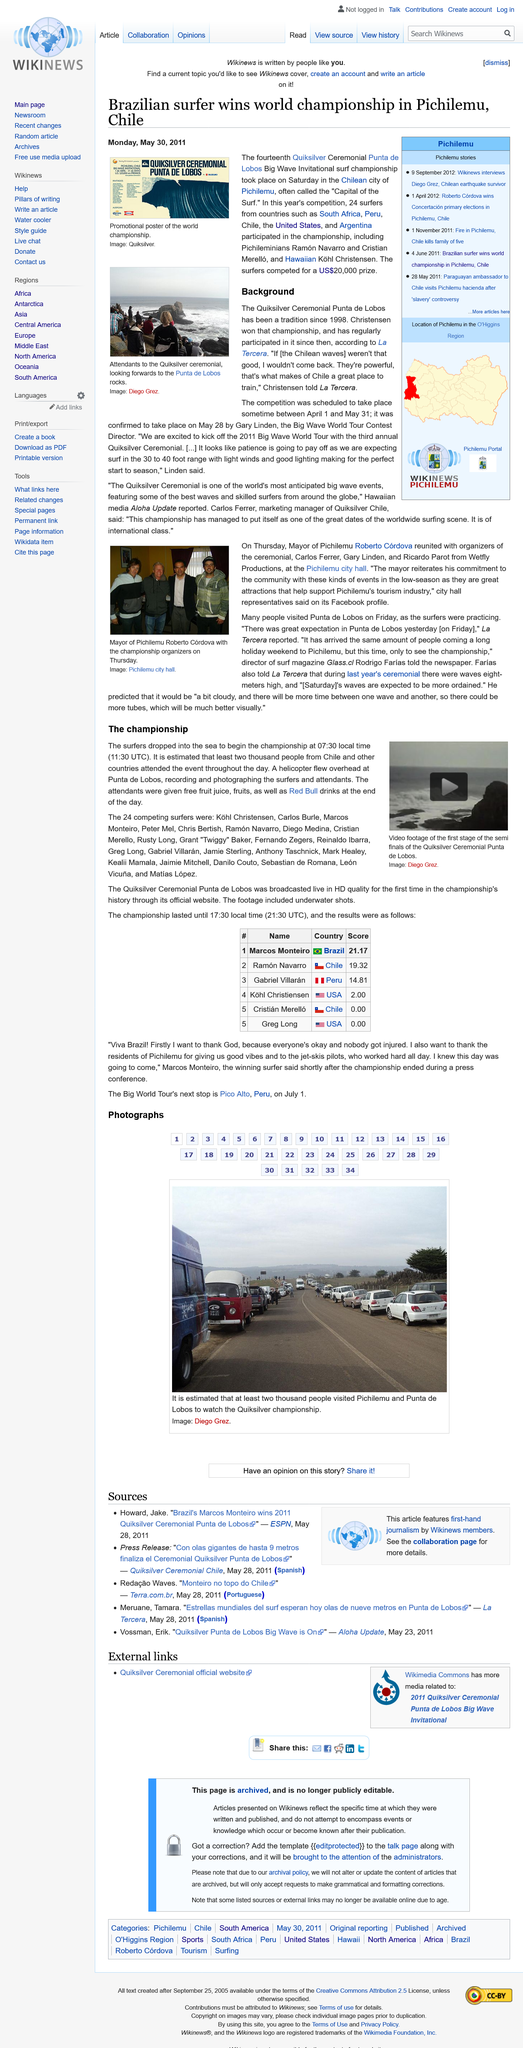Specify some key components in this picture. The video displays the initial stage of the semi-finals of the Quiksilver Ceremonial Punta de Lobos competition, capturing various moments of the event. The duration of the championship was from 7:30 in the morning until 5:30 in the evening. The fourteenth Quicksilver Ceremonial Punta de Lobos was participated in by twenty-four surfers. A total of 24 surfers participated in the competition. The first Quicksilver Ceremonial Punta de Lobos was won by Kohl Christensen. 